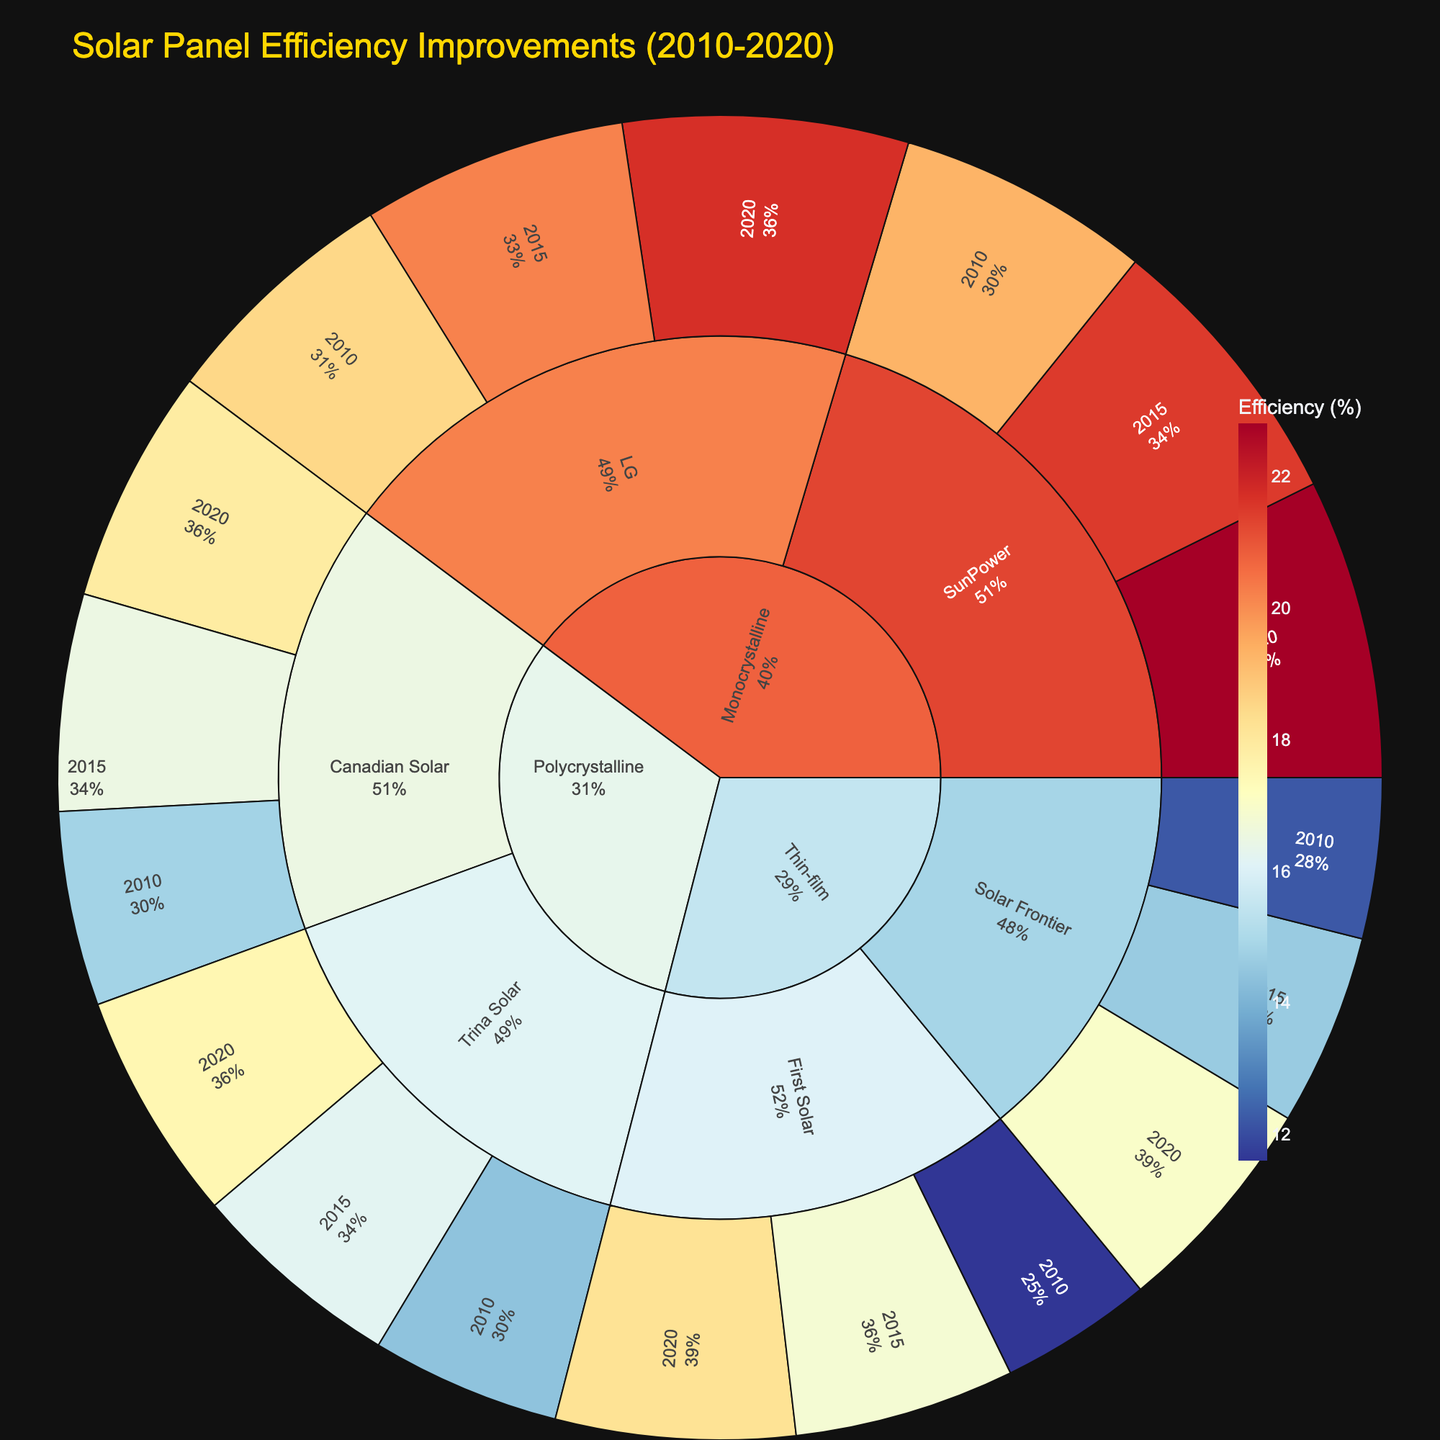What is the title of the plot? The title of the plot is typically displayed at the top of the figure. In this case, the plot's title reads "Solar Panel Efficiency Improvements (2010-2020)"
Answer: Solar Panel Efficiency Improvements (2010-2020) Which technology has the highest efficiency in 2020? To find the highest efficiency, look at the outermost ring for the year 2020 and examine efficiencies for Monocrystalline, Polycrystalline, and Thin-film technologies. Among them, Monocrystalline from SunPower has the highest efficiency.
Answer: Monocrystalline What is the efficiency improvement for Thin-film technology from 2010 to 2020? Thin-film technology's efficiency in 2010 for First Solar was 11.6% and in 2020 it was 18.2%. Compute the difference: 18.2% - 11.6% = 6.6%. For Solar Frontier, it's 12.2% in 2010 and 17.0% in 2020, resulting in an improvement of 17.0% - 12.2% = 4.8%.
Answer: 4.8%-6.6% Which manufacturer showed the highest efficiency gain in Polycrystalline technology from 2010 to 2020? Compare the efficiencies for Canadian Solar and Trina Solar from 2010 to 2020. Canadian Solar's efficiency improved from 14.8% to 17.9% (an increase of 3.1%), while Trina Solar's efficiency improved from 14.4% to 17.5% (an increase of 3.1%). Both manufacturers showed equal gains.
Answer: Canadian Solar and Trina Solar What is the average efficiency of all technologies in 2015? Sum the efficiency values of all technologies in 2015 and divide by the number of data points. This includes efficiencies for SunPower (21.5%), LG (20.2%), Canadian Solar (16.5%), Trina Solar (16.2%), First Solar (16.8%), and Solar Frontier (14.6%). Average = (21.5 + 20.2 + 16.5 + 16.2 + 16.8 + 14.6) / 6 = 17.6%
Answer: 17.6% Which manufacturer had the lowest efficiency in 2010? Check the efficiencies for each manufacturer in 2010. The values are SunPower (19.3%), LG (18.5%), Canadian Solar (14.8%), Trina Solar (14.4%), First Solar (11.6%), and Solar Frontier (12.2%). First Solar had the lowest efficiency in 2010.
Answer: First Solar How much did the efficiency of SunPower Monocrystalline panels increase from 2010 to 2020? SunPower Monocrystalline panels had efficiencies of 19.3% in 2010 and 22.8% in 2020. Calculate the difference: 22.8% - 19.3% = 3.5%.
Answer: 3.5% Which year had the greatest efficiency improvement for Solar Frontier Thin-film technology? Compare the improvements for Solar Frontier from 2010 to 2015 (14.6% - 12.2% = 2.4%) and from 2015 to 2020 (17.0% - 14.6% = 2.4%). Both periods saw equal improvements.
Answer: Both periods 2010-2015 and 2015-2020 What percentage of the total efficiency in 2020 is contributed by Monocrystalline SunPower technology? In 2020, the efficiencies are SunPower (22.8%), LG (21.7%), Canadian Solar (17.9%), Trina Solar (17.5%), First Solar (18.2%), and Solar Frontier (17.0%). Total is 22.8 + 21.7 + 17.9 + 17.5 + 18.2 + 17.0 = 115.1. SunPower's share is (22.8 / 115.1) * 100 ≈ 19.8%.
Answer: ~19.8% How does the efficiency of Trina Solar Polycrystalline panels in 2015 compare to LG Monocrystalline panels in the same year? Trina Solar Polycrystalline panels had an efficiency of 16.2% in 2015, while LG Monocrystalline panels had an efficiency of 20.2%. LG Monocrystalline panels were more efficient.
Answer: LG Monocrystalline 